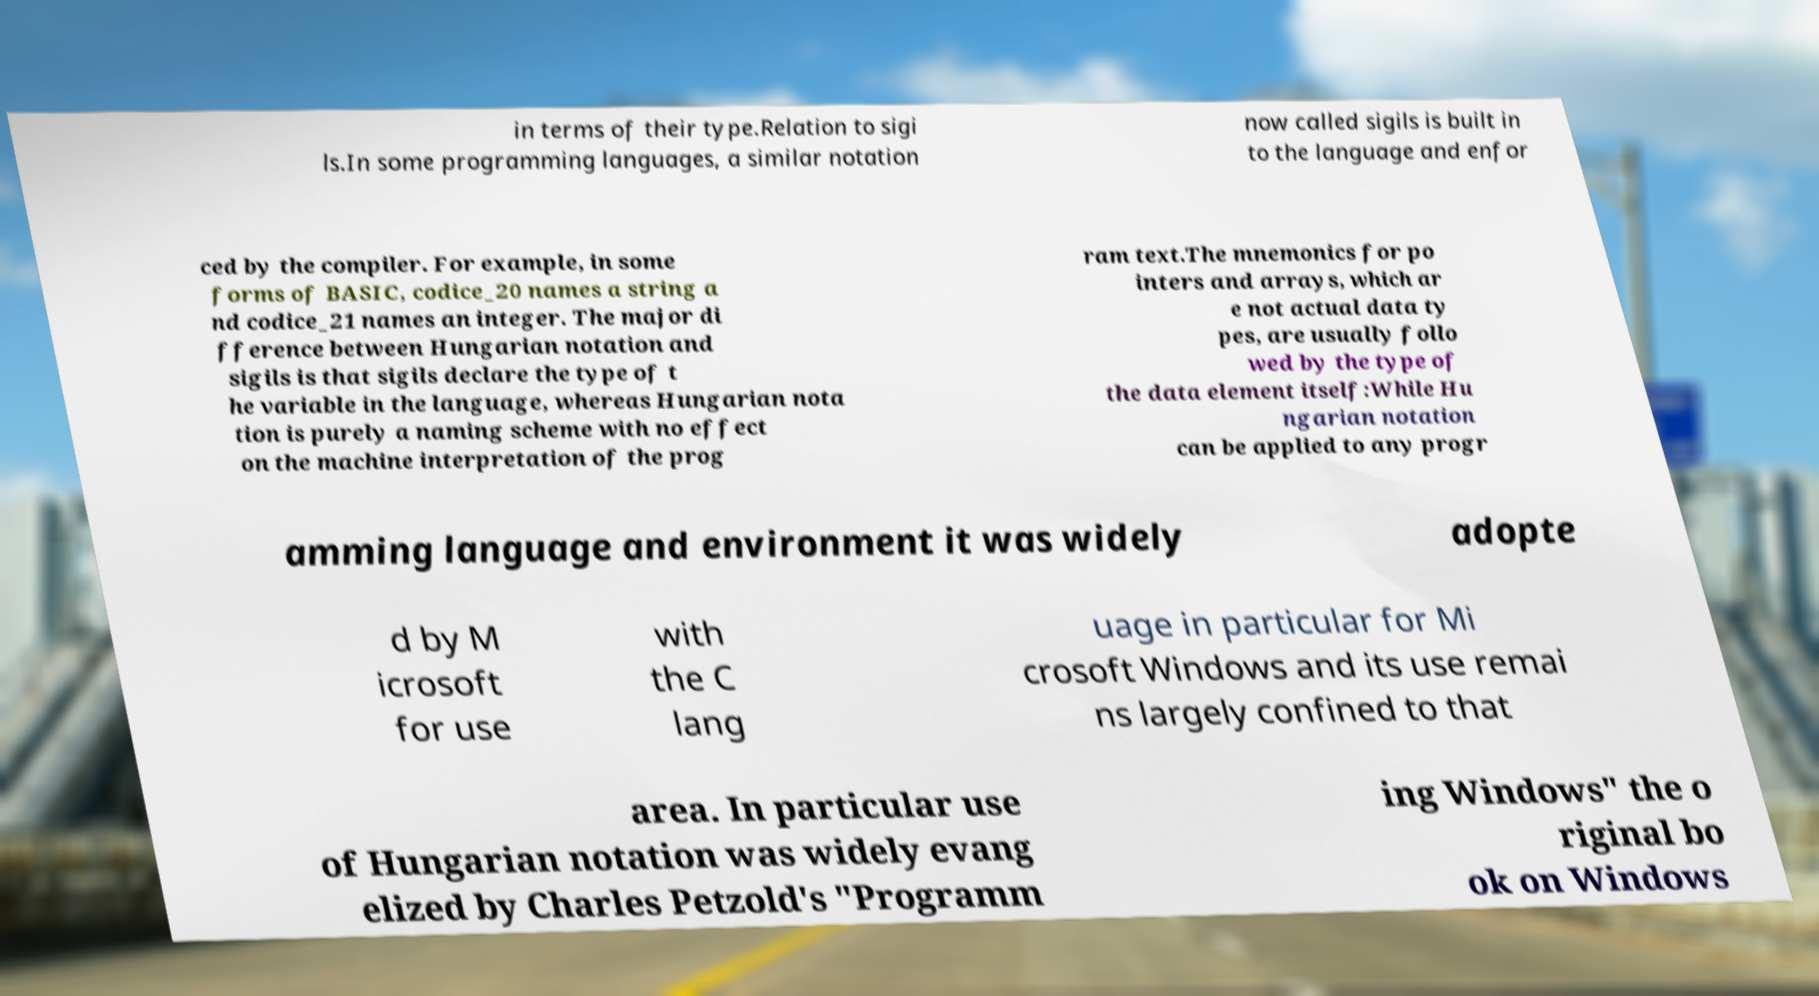Please read and relay the text visible in this image. What does it say? in terms of their type.Relation to sigi ls.In some programming languages, a similar notation now called sigils is built in to the language and enfor ced by the compiler. For example, in some forms of BASIC, codice_20 names a string a nd codice_21 names an integer. The major di fference between Hungarian notation and sigils is that sigils declare the type of t he variable in the language, whereas Hungarian nota tion is purely a naming scheme with no effect on the machine interpretation of the prog ram text.The mnemonics for po inters and arrays, which ar e not actual data ty pes, are usually follo wed by the type of the data element itself:While Hu ngarian notation can be applied to any progr amming language and environment it was widely adopte d by M icrosoft for use with the C lang uage in particular for Mi crosoft Windows and its use remai ns largely confined to that area. In particular use of Hungarian notation was widely evang elized by Charles Petzold's "Programm ing Windows" the o riginal bo ok on Windows 